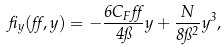Convert formula to latex. <formula><loc_0><loc_0><loc_500><loc_500>\beta _ { y } ( \alpha , y ) = - \frac { 6 C _ { F } \alpha } { 4 \pi } y + \frac { N } { 8 \pi ^ { 2 } } y ^ { 3 } ,</formula> 